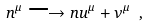Convert formula to latex. <formula><loc_0><loc_0><loc_500><loc_500>n ^ { \mu } \longrightarrow n u ^ { \mu } + \nu ^ { \mu } \ ,</formula> 